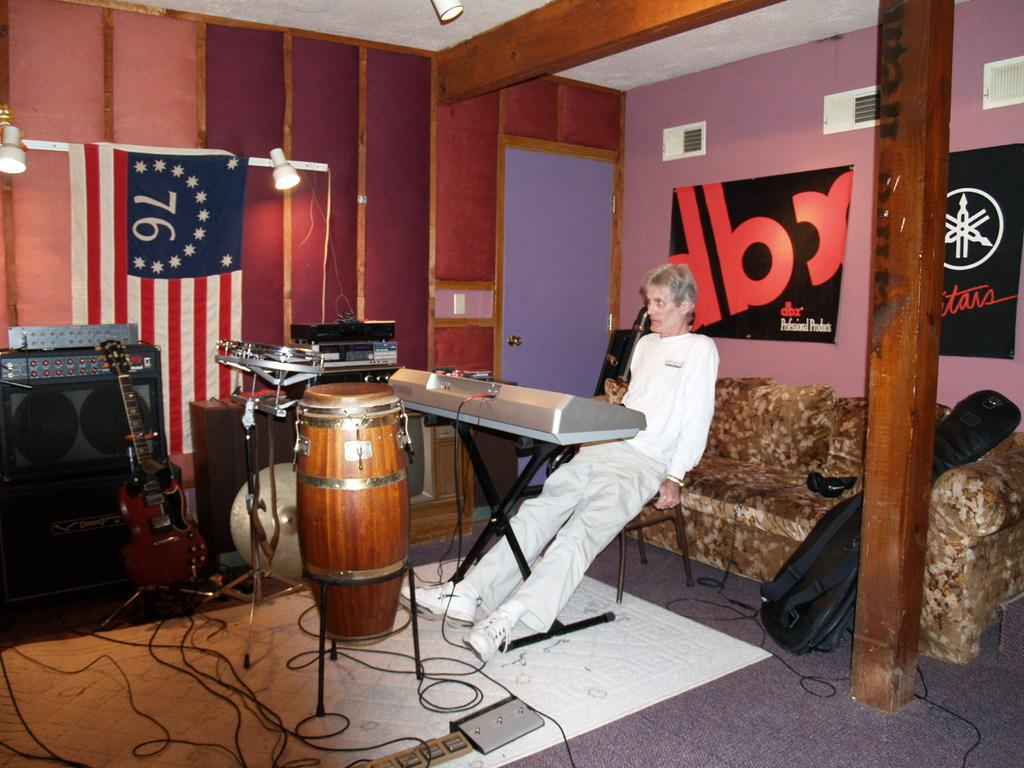What is the person in the image doing? The person is sitting on a chair in the image. What type of furniture is also present in the image? There is a sofa in the image. What can be seen on the wall in the image? There is a flag in the image. What musical instruments are visible in the image? There are drums and a sound box in the image. What type of popcorn is being served to the passengers in the image? There is no popcorn or passengers present in the image. What country is the person in the image from? The image does not provide information about the person's nationality or country of origin. 